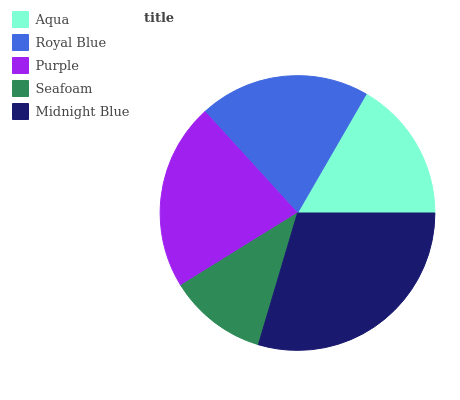Is Seafoam the minimum?
Answer yes or no. Yes. Is Midnight Blue the maximum?
Answer yes or no. Yes. Is Royal Blue the minimum?
Answer yes or no. No. Is Royal Blue the maximum?
Answer yes or no. No. Is Royal Blue greater than Aqua?
Answer yes or no. Yes. Is Aqua less than Royal Blue?
Answer yes or no. Yes. Is Aqua greater than Royal Blue?
Answer yes or no. No. Is Royal Blue less than Aqua?
Answer yes or no. No. Is Royal Blue the high median?
Answer yes or no. Yes. Is Royal Blue the low median?
Answer yes or no. Yes. Is Seafoam the high median?
Answer yes or no. No. Is Purple the low median?
Answer yes or no. No. 